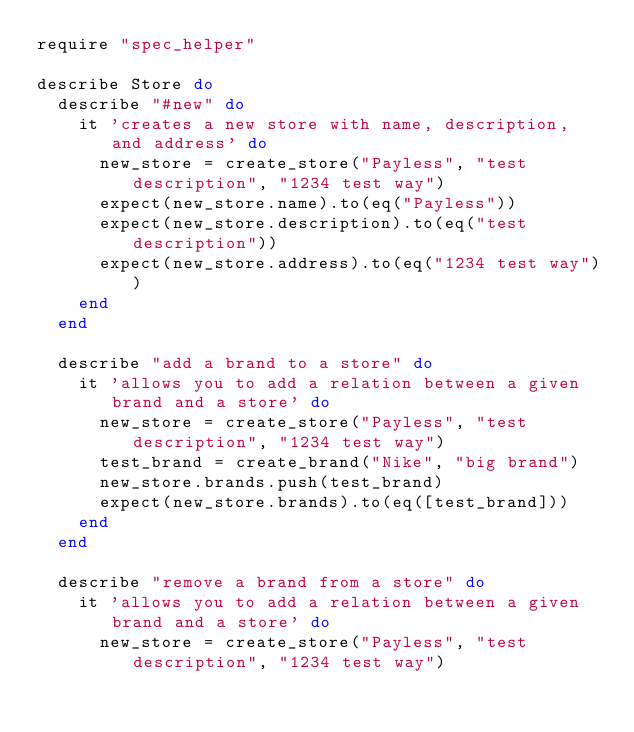<code> <loc_0><loc_0><loc_500><loc_500><_Ruby_>require "spec_helper"

describe Store do
  describe "#new" do
    it 'creates a new store with name, description, and address' do
      new_store = create_store("Payless", "test description", "1234 test way")
      expect(new_store.name).to(eq("Payless"))
      expect(new_store.description).to(eq("test description"))
      expect(new_store.address).to(eq("1234 test way"))
    end
  end

  describe "add a brand to a store" do
    it 'allows you to add a relation between a given brand and a store' do
      new_store = create_store("Payless", "test description", "1234 test way")
      test_brand = create_brand("Nike", "big brand")
      new_store.brands.push(test_brand)
      expect(new_store.brands).to(eq([test_brand]))
    end
  end

  describe "remove a brand from a store" do
    it 'allows you to add a relation between a given brand and a store' do
      new_store = create_store("Payless", "test description", "1234 test way")</code> 